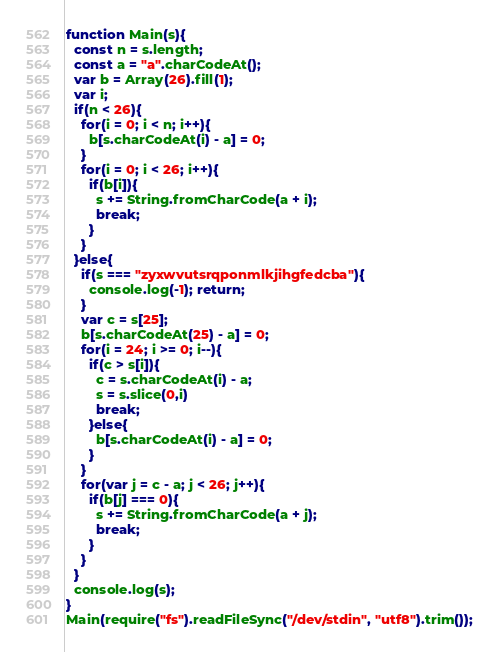<code> <loc_0><loc_0><loc_500><loc_500><_JavaScript_>function Main(s){
  const n = s.length;
  const a = "a".charCodeAt();
  var b = Array(26).fill(1);
  var i;
  if(n < 26){
    for(i = 0; i < n; i++){
      b[s.charCodeAt(i) - a] = 0;
    }
    for(i = 0; i < 26; i++){
      if(b[i]){
        s += String.fromCharCode(a + i);
        break;
      }
    }
  }else{
    if(s === "zyxwvutsrqponmlkjihgfedcba"){
      console.log(-1); return;
    }
    var c = s[25];
    b[s.charCodeAt(25) - a] = 0;
    for(i = 24; i >= 0; i--){
      if(c > s[i]){
        c = s.charCodeAt(i) - a;
        s = s.slice(0,i)
        break;
      }else{
        b[s.charCodeAt(i) - a] = 0;
      }
    }
    for(var j = c - a; j < 26; j++){
      if(b[j] === 0){
        s += String.fromCharCode(a + j);
        break;
      }
    }
  }
  console.log(s);
}
Main(require("fs").readFileSync("/dev/stdin", "utf8").trim());</code> 